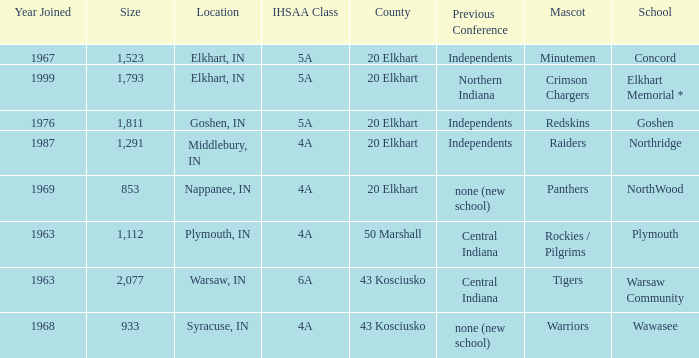What country joined before 1976, with IHSSA class of 5a, and a size larger than 1,112? 20 Elkhart. 